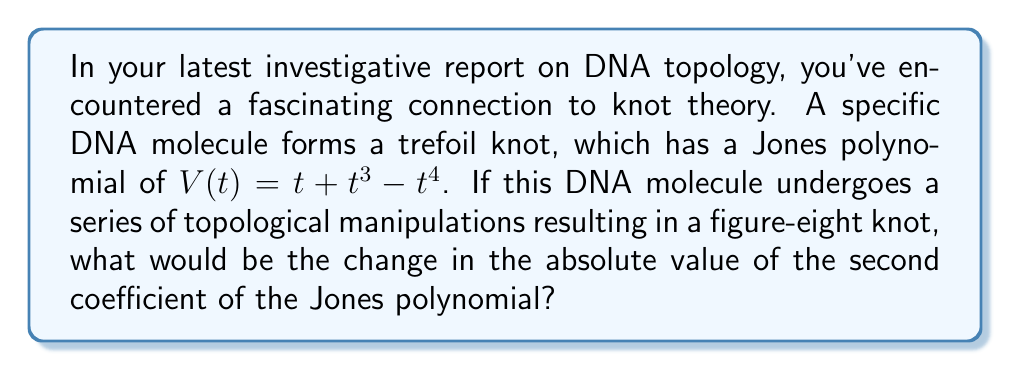Help me with this question. Let's approach this step-by-step:

1) First, recall that the Jones polynomial for a trefoil knot is:
   $V(t) = t + t^3 - t^4$

2) The second coefficient in this polynomial is 0 (the coefficient of $t^2$).

3) Now, for the figure-eight knot, the Jones polynomial is:
   $V(t) = t^{-2} - t^{-1} + 1 - t + t^2$

4) We can rewrite this in ascending powers of t:
   $V(t) = t^{-2} - t^{-1} + 1 - t + t^2$

5) In this form, the second coefficient (of $t^{-1}$) is -1.

6) To find the change in the absolute value of the second coefficient, we calculate:
   $|$Second coefficient of figure-eight knot$| - |$Second coefficient of trefoil knot$|$
   $= |-1| - |0| = 1 - 0 = 1$

Therefore, the change in the absolute value of the second coefficient is 1.
Answer: 1 